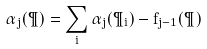<formula> <loc_0><loc_0><loc_500><loc_500>\alpha _ { j } ( \P ) = \sum _ { i } \alpha _ { j } ( \P _ { i } ) - f _ { j - 1 } ( \P )</formula> 